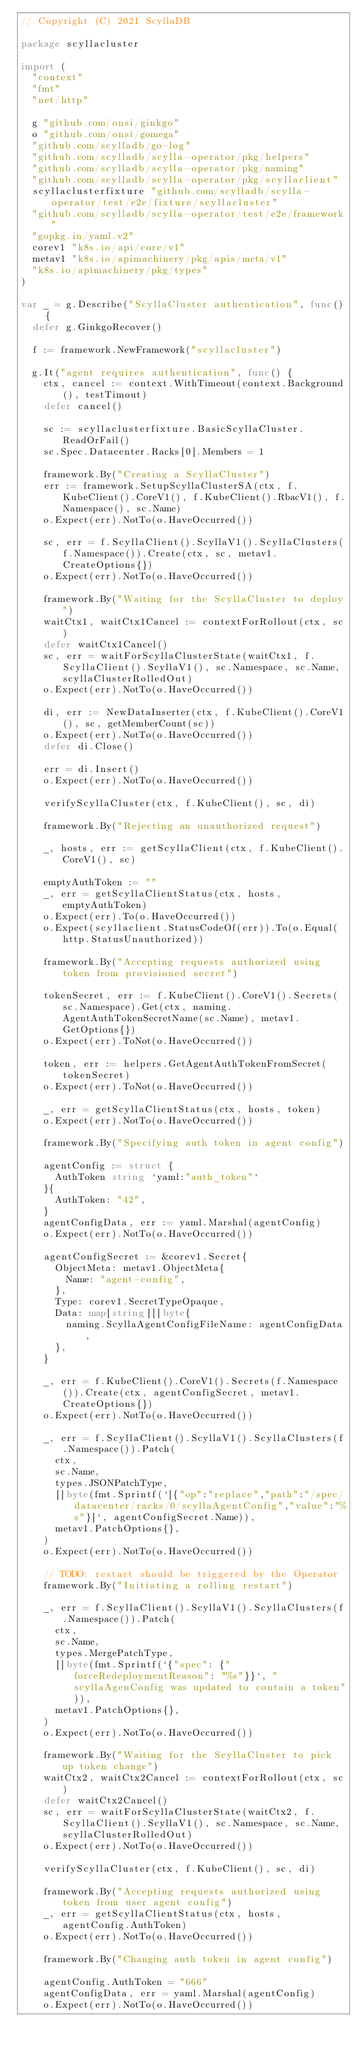<code> <loc_0><loc_0><loc_500><loc_500><_Go_>// Copyright (C) 2021 ScyllaDB

package scyllacluster

import (
	"context"
	"fmt"
	"net/http"

	g "github.com/onsi/ginkgo"
	o "github.com/onsi/gomega"
	"github.com/scylladb/go-log"
	"github.com/scylladb/scylla-operator/pkg/helpers"
	"github.com/scylladb/scylla-operator/pkg/naming"
	"github.com/scylladb/scylla-operator/pkg/scyllaclient"
	scyllaclusterfixture "github.com/scylladb/scylla-operator/test/e2e/fixture/scyllacluster"
	"github.com/scylladb/scylla-operator/test/e2e/framework"
	"gopkg.in/yaml.v2"
	corev1 "k8s.io/api/core/v1"
	metav1 "k8s.io/apimachinery/pkg/apis/meta/v1"
	"k8s.io/apimachinery/pkg/types"
)

var _ = g.Describe("ScyllaCluster authentication", func() {
	defer g.GinkgoRecover()

	f := framework.NewFramework("scyllacluster")

	g.It("agent requires authentication", func() {
		ctx, cancel := context.WithTimeout(context.Background(), testTimout)
		defer cancel()

		sc := scyllaclusterfixture.BasicScyllaCluster.ReadOrFail()
		sc.Spec.Datacenter.Racks[0].Members = 1

		framework.By("Creating a ScyllaCluster")
		err := framework.SetupScyllaClusterSA(ctx, f.KubeClient().CoreV1(), f.KubeClient().RbacV1(), f.Namespace(), sc.Name)
		o.Expect(err).NotTo(o.HaveOccurred())

		sc, err = f.ScyllaClient().ScyllaV1().ScyllaClusters(f.Namespace()).Create(ctx, sc, metav1.CreateOptions{})
		o.Expect(err).NotTo(o.HaveOccurred())

		framework.By("Waiting for the ScyllaCluster to deploy")
		waitCtx1, waitCtx1Cancel := contextForRollout(ctx, sc)
		defer waitCtx1Cancel()
		sc, err = waitForScyllaClusterState(waitCtx1, f.ScyllaClient().ScyllaV1(), sc.Namespace, sc.Name, scyllaClusterRolledOut)
		o.Expect(err).NotTo(o.HaveOccurred())

		di, err := NewDataInserter(ctx, f.KubeClient().CoreV1(), sc, getMemberCount(sc))
		o.Expect(err).NotTo(o.HaveOccurred())
		defer di.Close()

		err = di.Insert()
		o.Expect(err).NotTo(o.HaveOccurred())

		verifyScyllaCluster(ctx, f.KubeClient(), sc, di)

		framework.By("Rejecting an unauthorized request")

		_, hosts, err := getScyllaClient(ctx, f.KubeClient().CoreV1(), sc)

		emptyAuthToken := ""
		_, err = getScyllaClientStatus(ctx, hosts, emptyAuthToken)
		o.Expect(err).To(o.HaveOccurred())
		o.Expect(scyllaclient.StatusCodeOf(err)).To(o.Equal(http.StatusUnauthorized))

		framework.By("Accepting requests authorized using token from provisioned secret")

		tokenSecret, err := f.KubeClient().CoreV1().Secrets(sc.Namespace).Get(ctx, naming.AgentAuthTokenSecretName(sc.Name), metav1.GetOptions{})
		o.Expect(err).ToNot(o.HaveOccurred())

		token, err := helpers.GetAgentAuthTokenFromSecret(tokenSecret)
		o.Expect(err).ToNot(o.HaveOccurred())

		_, err = getScyllaClientStatus(ctx, hosts, token)
		o.Expect(err).NotTo(o.HaveOccurred())

		framework.By("Specifying auth token in agent config")

		agentConfig := struct {
			AuthToken string `yaml:"auth_token"`
		}{
			AuthToken: "42",
		}
		agentConfigData, err := yaml.Marshal(agentConfig)
		o.Expect(err).NotTo(o.HaveOccurred())

		agentConfigSecret := &corev1.Secret{
			ObjectMeta: metav1.ObjectMeta{
				Name: "agent-config",
			},
			Type: corev1.SecretTypeOpaque,
			Data: map[string][]byte{
				naming.ScyllaAgentConfigFileName: agentConfigData,
			},
		}

		_, err = f.KubeClient().CoreV1().Secrets(f.Namespace()).Create(ctx, agentConfigSecret, metav1.CreateOptions{})
		o.Expect(err).NotTo(o.HaveOccurred())

		_, err = f.ScyllaClient().ScyllaV1().ScyllaClusters(f.Namespace()).Patch(
			ctx,
			sc.Name,
			types.JSONPatchType,
			[]byte(fmt.Sprintf(`[{"op":"replace","path":"/spec/datacenter/racks/0/scyllaAgentConfig","value":"%s"}]`, agentConfigSecret.Name)),
			metav1.PatchOptions{},
		)
		o.Expect(err).NotTo(o.HaveOccurred())

		// TODO: restart should be triggered by the Operator
		framework.By("Initiating a rolling restart")

		_, err = f.ScyllaClient().ScyllaV1().ScyllaClusters(f.Namespace()).Patch(
			ctx,
			sc.Name,
			types.MergePatchType,
			[]byte(fmt.Sprintf(`{"spec": {"forceRedeploymentReason": "%s"}}`, "scyllaAgenConfig was updated to contain a token")),
			metav1.PatchOptions{},
		)
		o.Expect(err).NotTo(o.HaveOccurred())

		framework.By("Waiting for the ScyllaCluster to pick up token change")
		waitCtx2, waitCtx2Cancel := contextForRollout(ctx, sc)
		defer waitCtx2Cancel()
		sc, err = waitForScyllaClusterState(waitCtx2, f.ScyllaClient().ScyllaV1(), sc.Namespace, sc.Name, scyllaClusterRolledOut)
		o.Expect(err).NotTo(o.HaveOccurred())

		verifyScyllaCluster(ctx, f.KubeClient(), sc, di)

		framework.By("Accepting requests authorized using token from user agent config")
		_, err = getScyllaClientStatus(ctx, hosts, agentConfig.AuthToken)
		o.Expect(err).NotTo(o.HaveOccurred())

		framework.By("Changing auth token in agent config")

		agentConfig.AuthToken = "666"
		agentConfigData, err = yaml.Marshal(agentConfig)
		o.Expect(err).NotTo(o.HaveOccurred())</code> 